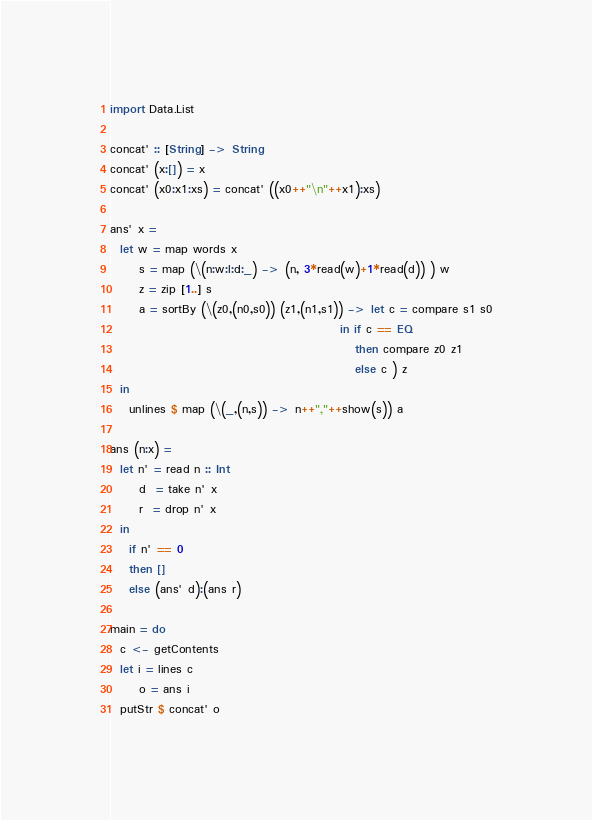Convert code to text. <code><loc_0><loc_0><loc_500><loc_500><_Haskell_>import Data.List

concat' :: [String] -> String
concat' (x:[]) = x
concat' (x0:x1:xs) = concat' ((x0++"\n"++x1):xs)

ans' x =
  let w = map words x
      s = map (\(n:w:l:d:_) -> (n, 3*read(w)+1*read(d)) ) w
      z = zip [1..] s
      a = sortBy (\(z0,(n0,s0)) (z1,(n1,s1)) -> let c = compare s1 s0
                                                in if c == EQ
                                                   then compare z0 z1
                                                   else c ) z
  in
    unlines $ map (\(_,(n,s)) -> n++","++show(s)) a

ans (n:x) =
  let n' = read n :: Int
      d  = take n' x
      r  = drop n' x
  in
    if n' == 0
    then []
    else (ans' d):(ans r)

main = do
  c <- getContents
  let i = lines c
      o = ans i
  putStr $ concat' o</code> 